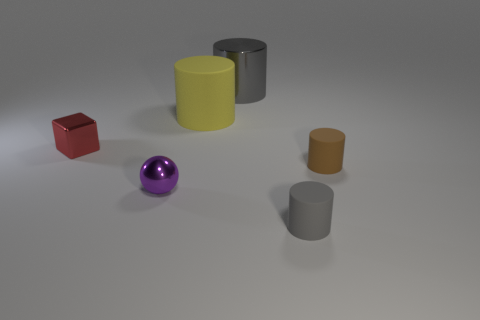There is a big cylinder that is behind the rubber cylinder on the left side of the tiny gray cylinder; are there any small gray matte objects left of it?
Offer a very short reply. No. There is a tiny red metal cube; are there any matte things in front of it?
Your answer should be very brief. Yes. How many shiny blocks are the same color as the big rubber cylinder?
Offer a terse response. 0. What is the size of the cylinder that is made of the same material as the small red block?
Your response must be concise. Large. There is a gray cylinder on the left side of the gray cylinder right of the gray cylinder behind the tiny gray cylinder; what size is it?
Your answer should be compact. Large. There is a gray thing that is behind the metallic ball; what is its size?
Provide a succinct answer. Large. How many gray things are large cylinders or small metallic cubes?
Ensure brevity in your answer.  1. Are there any other things that have the same size as the brown object?
Ensure brevity in your answer.  Yes. What is the material of the brown thing that is the same size as the sphere?
Your response must be concise. Rubber. Do the gray cylinder that is behind the purple object and the metallic thing in front of the tiny red metallic block have the same size?
Offer a terse response. No. 